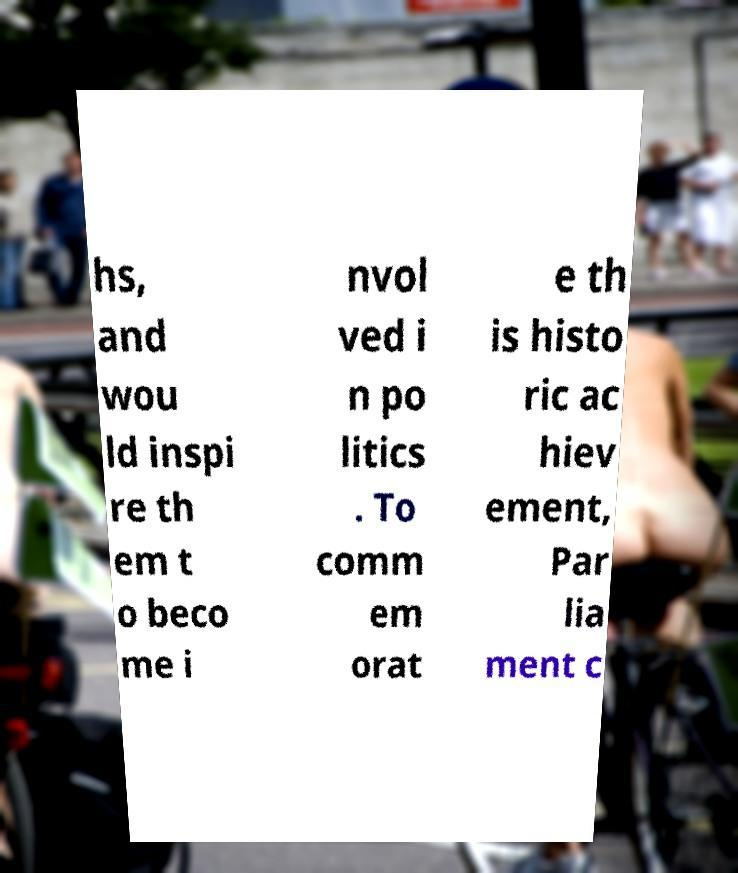Can you read and provide the text displayed in the image?This photo seems to have some interesting text. Can you extract and type it out for me? hs, and wou ld inspi re th em t o beco me i nvol ved i n po litics . To comm em orat e th is histo ric ac hiev ement, Par lia ment c 